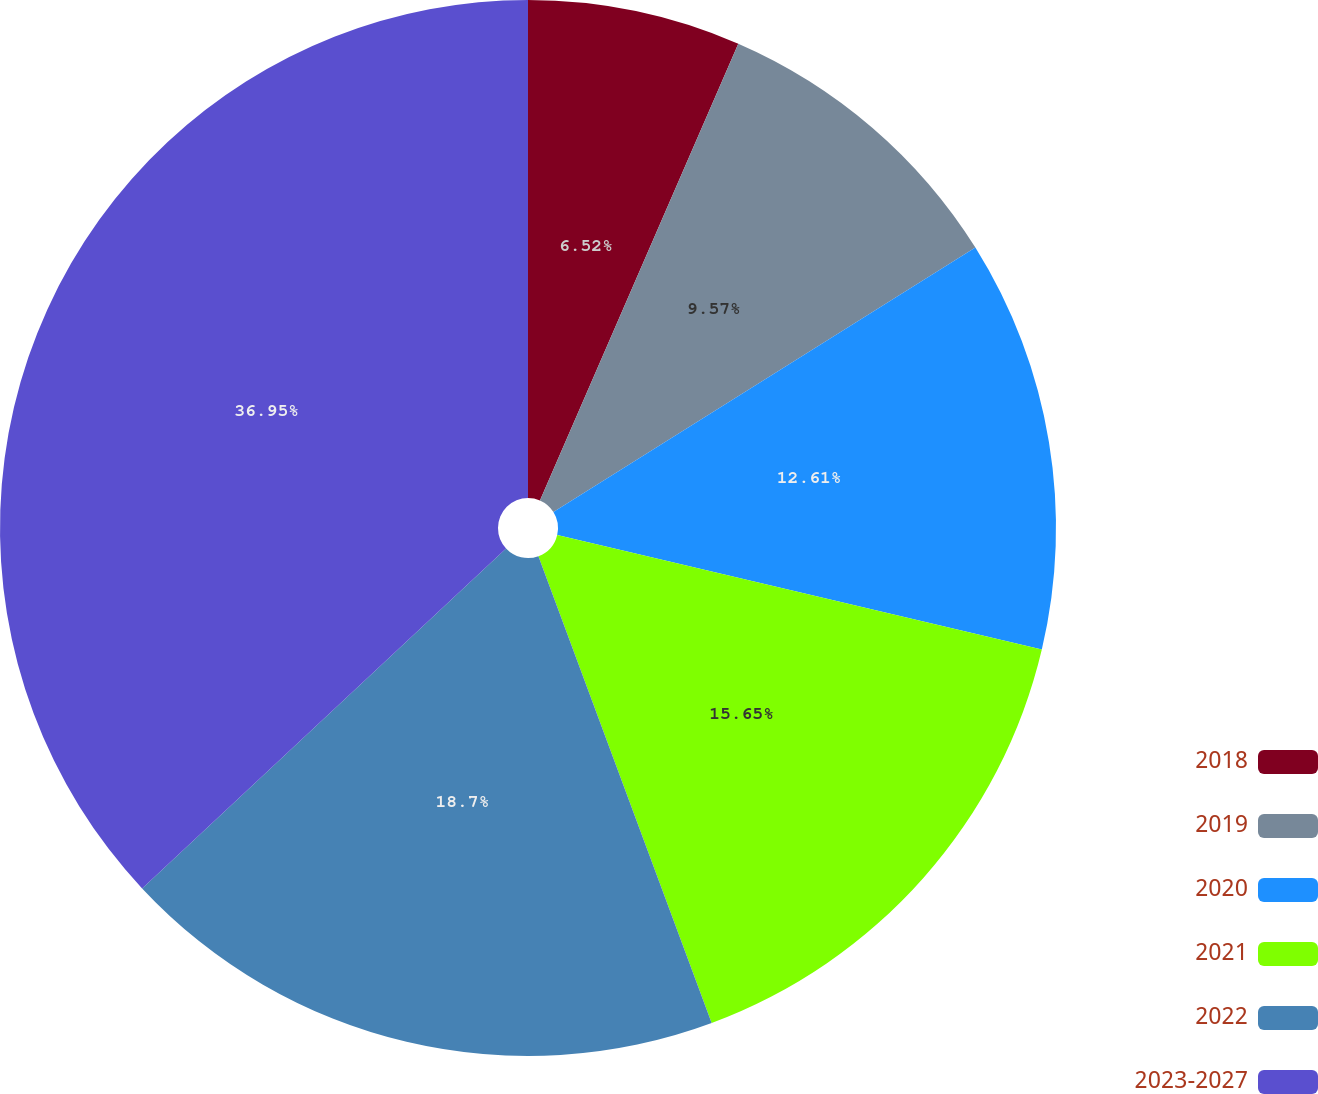Convert chart. <chart><loc_0><loc_0><loc_500><loc_500><pie_chart><fcel>2018<fcel>2019<fcel>2020<fcel>2021<fcel>2022<fcel>2023-2027<nl><fcel>6.52%<fcel>9.57%<fcel>12.61%<fcel>15.65%<fcel>18.7%<fcel>36.96%<nl></chart> 